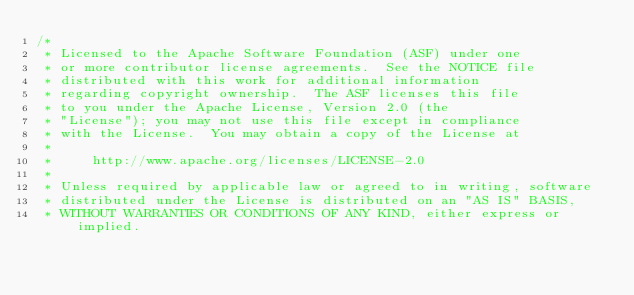<code> <loc_0><loc_0><loc_500><loc_500><_Java_>/*
 * Licensed to the Apache Software Foundation (ASF) under one
 * or more contributor license agreements.  See the NOTICE file
 * distributed with this work for additional information
 * regarding copyright ownership.  The ASF licenses this file
 * to you under the Apache License, Version 2.0 (the
 * "License"); you may not use this file except in compliance
 * with the License.  You may obtain a copy of the License at
 *
 *     http://www.apache.org/licenses/LICENSE-2.0
 *
 * Unless required by applicable law or agreed to in writing, software
 * distributed under the License is distributed on an "AS IS" BASIS,
 * WITHOUT WARRANTIES OR CONDITIONS OF ANY KIND, either express or implied.</code> 